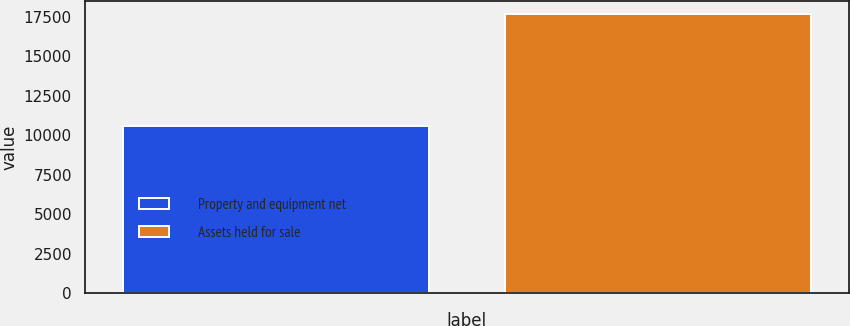<chart> <loc_0><loc_0><loc_500><loc_500><bar_chart><fcel>Property and equipment net<fcel>Assets held for sale<nl><fcel>10558<fcel>17651<nl></chart> 